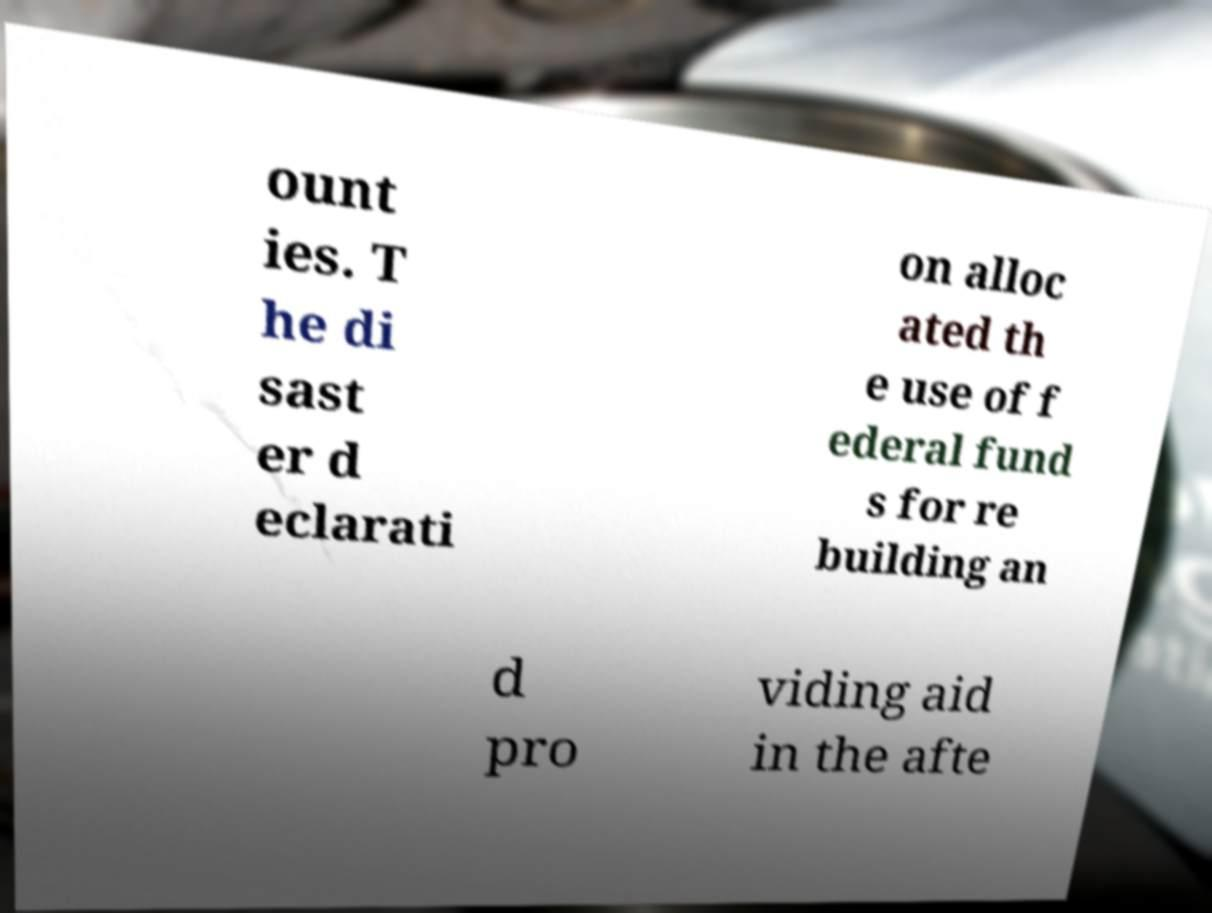Can you accurately transcribe the text from the provided image for me? ount ies. T he di sast er d eclarati on alloc ated th e use of f ederal fund s for re building an d pro viding aid in the afte 